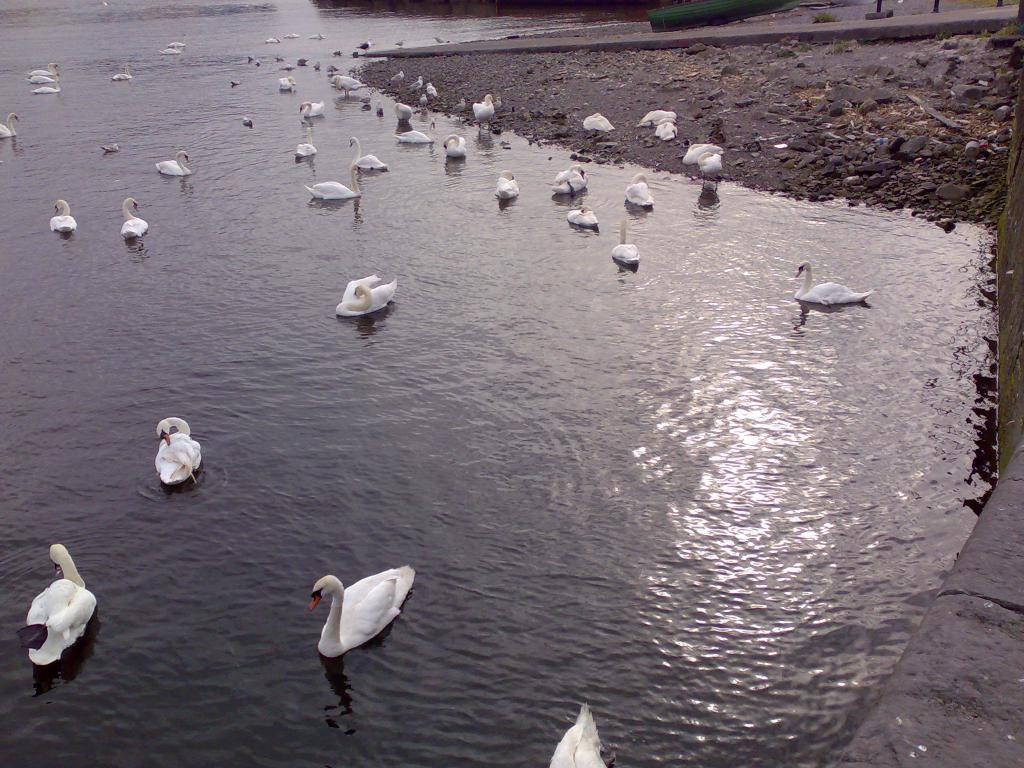What is the main subject of the image? The main subject of the image is a swan lake. Are there any other elements present in the image besides the swan lake? Yes, there are stones and mud in the right top corner of the image. What type of milk can be seen in the image? There is no milk present in the image. Can you describe the texture of the house in the image? There is no house present in the image. 